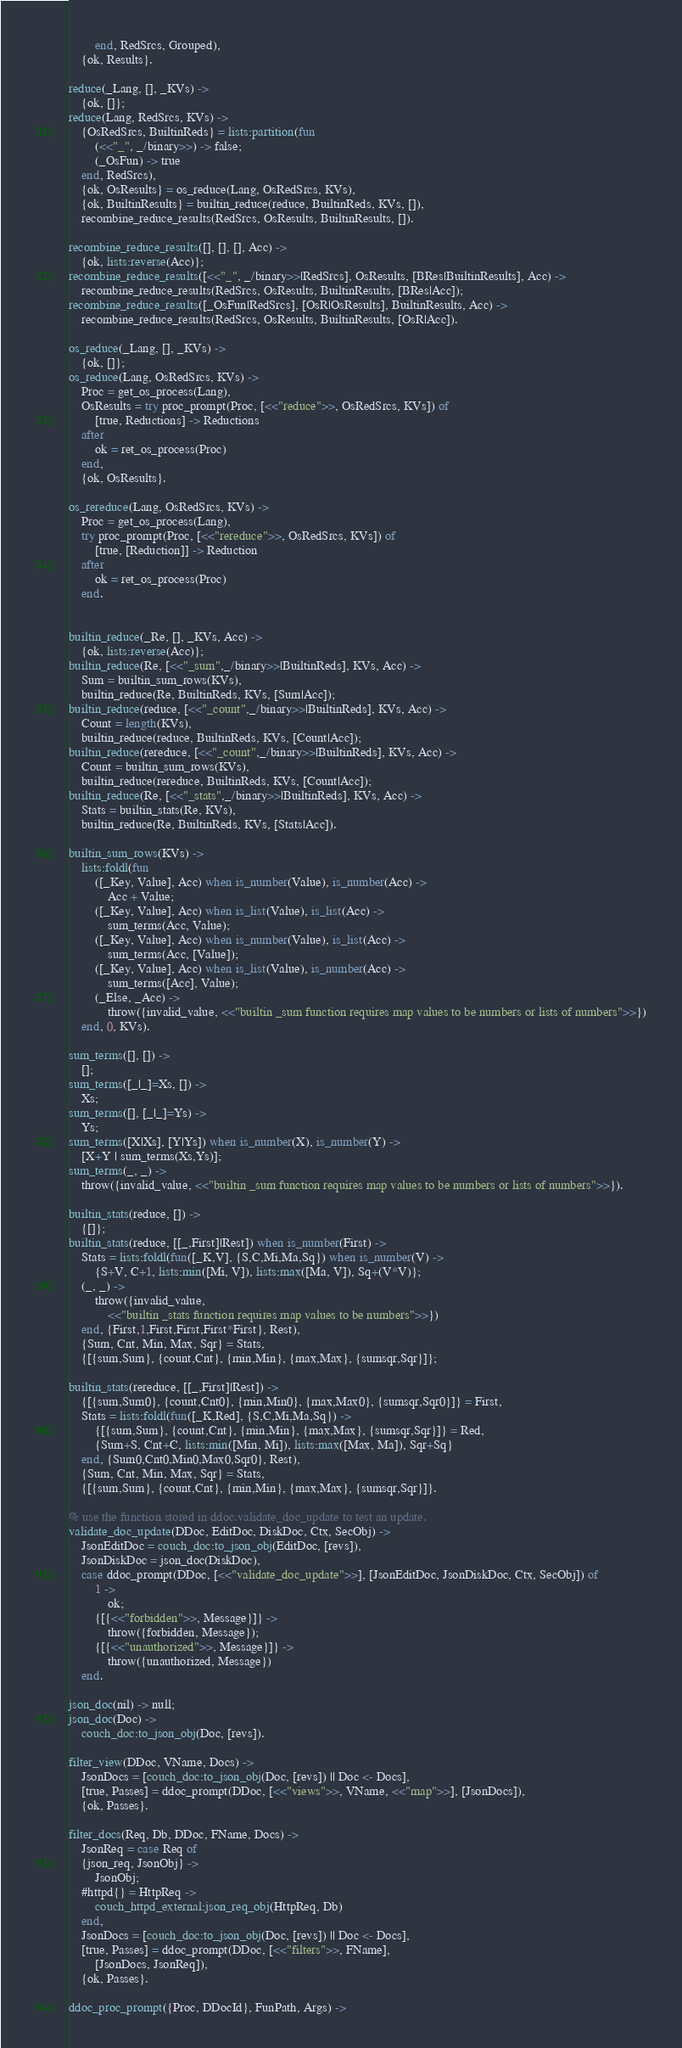Convert code to text. <code><loc_0><loc_0><loc_500><loc_500><_Erlang_>        end, RedSrcs, Grouped),
    {ok, Results}.

reduce(_Lang, [], _KVs) ->
    {ok, []};
reduce(Lang, RedSrcs, KVs) ->
    {OsRedSrcs, BuiltinReds} = lists:partition(fun
        (<<"_", _/binary>>) -> false;
        (_OsFun) -> true
    end, RedSrcs),
    {ok, OsResults} = os_reduce(Lang, OsRedSrcs, KVs),
    {ok, BuiltinResults} = builtin_reduce(reduce, BuiltinReds, KVs, []),
    recombine_reduce_results(RedSrcs, OsResults, BuiltinResults, []).

recombine_reduce_results([], [], [], Acc) ->
    {ok, lists:reverse(Acc)};
recombine_reduce_results([<<"_", _/binary>>|RedSrcs], OsResults, [BRes|BuiltinResults], Acc) ->
    recombine_reduce_results(RedSrcs, OsResults, BuiltinResults, [BRes|Acc]);
recombine_reduce_results([_OsFun|RedSrcs], [OsR|OsResults], BuiltinResults, Acc) ->
    recombine_reduce_results(RedSrcs, OsResults, BuiltinResults, [OsR|Acc]).

os_reduce(_Lang, [], _KVs) ->
    {ok, []};
os_reduce(Lang, OsRedSrcs, KVs) ->
    Proc = get_os_process(Lang),
    OsResults = try proc_prompt(Proc, [<<"reduce">>, OsRedSrcs, KVs]) of
        [true, Reductions] -> Reductions
    after
        ok = ret_os_process(Proc)
    end,
    {ok, OsResults}.

os_rereduce(Lang, OsRedSrcs, KVs) ->
    Proc = get_os_process(Lang),
    try proc_prompt(Proc, [<<"rereduce">>, OsRedSrcs, KVs]) of
        [true, [Reduction]] -> Reduction
    after
        ok = ret_os_process(Proc)
    end.


builtin_reduce(_Re, [], _KVs, Acc) ->
    {ok, lists:reverse(Acc)};
builtin_reduce(Re, [<<"_sum",_/binary>>|BuiltinReds], KVs, Acc) ->
    Sum = builtin_sum_rows(KVs),
    builtin_reduce(Re, BuiltinReds, KVs, [Sum|Acc]);
builtin_reduce(reduce, [<<"_count",_/binary>>|BuiltinReds], KVs, Acc) ->
    Count = length(KVs),
    builtin_reduce(reduce, BuiltinReds, KVs, [Count|Acc]);
builtin_reduce(rereduce, [<<"_count",_/binary>>|BuiltinReds], KVs, Acc) ->
    Count = builtin_sum_rows(KVs),
    builtin_reduce(rereduce, BuiltinReds, KVs, [Count|Acc]);
builtin_reduce(Re, [<<"_stats",_/binary>>|BuiltinReds], KVs, Acc) ->
    Stats = builtin_stats(Re, KVs),
    builtin_reduce(Re, BuiltinReds, KVs, [Stats|Acc]).

builtin_sum_rows(KVs) ->
    lists:foldl(fun
        ([_Key, Value], Acc) when is_number(Value), is_number(Acc) ->
            Acc + Value;
        ([_Key, Value], Acc) when is_list(Value), is_list(Acc) ->
            sum_terms(Acc, Value);
        ([_Key, Value], Acc) when is_number(Value), is_list(Acc) ->
            sum_terms(Acc, [Value]);
        ([_Key, Value], Acc) when is_list(Value), is_number(Acc) ->
            sum_terms([Acc], Value);
        (_Else, _Acc) ->
            throw({invalid_value, <<"builtin _sum function requires map values to be numbers or lists of numbers">>})
    end, 0, KVs).

sum_terms([], []) ->
    [];
sum_terms([_|_]=Xs, []) ->
    Xs;
sum_terms([], [_|_]=Ys) ->
    Ys;
sum_terms([X|Xs], [Y|Ys]) when is_number(X), is_number(Y) ->
    [X+Y | sum_terms(Xs,Ys)];
sum_terms(_, _) ->
    throw({invalid_value, <<"builtin _sum function requires map values to be numbers or lists of numbers">>}).

builtin_stats(reduce, []) ->
    {[]};
builtin_stats(reduce, [[_,First]|Rest]) when is_number(First) ->
    Stats = lists:foldl(fun([_K,V], {S,C,Mi,Ma,Sq}) when is_number(V) ->
        {S+V, C+1, lists:min([Mi, V]), lists:max([Ma, V]), Sq+(V*V)};
    (_, _) ->
        throw({invalid_value,
            <<"builtin _stats function requires map values to be numbers">>})
    end, {First,1,First,First,First*First}, Rest),
    {Sum, Cnt, Min, Max, Sqr} = Stats,
    {[{sum,Sum}, {count,Cnt}, {min,Min}, {max,Max}, {sumsqr,Sqr}]};

builtin_stats(rereduce, [[_,First]|Rest]) ->
    {[{sum,Sum0}, {count,Cnt0}, {min,Min0}, {max,Max0}, {sumsqr,Sqr0}]} = First,
    Stats = lists:foldl(fun([_K,Red], {S,C,Mi,Ma,Sq}) ->
        {[{sum,Sum}, {count,Cnt}, {min,Min}, {max,Max}, {sumsqr,Sqr}]} = Red,
        {Sum+S, Cnt+C, lists:min([Min, Mi]), lists:max([Max, Ma]), Sqr+Sq}
    end, {Sum0,Cnt0,Min0,Max0,Sqr0}, Rest),
    {Sum, Cnt, Min, Max, Sqr} = Stats,
    {[{sum,Sum}, {count,Cnt}, {min,Min}, {max,Max}, {sumsqr,Sqr}]}.

% use the function stored in ddoc.validate_doc_update to test an update.
validate_doc_update(DDoc, EditDoc, DiskDoc, Ctx, SecObj) ->
    JsonEditDoc = couch_doc:to_json_obj(EditDoc, [revs]),
    JsonDiskDoc = json_doc(DiskDoc),
    case ddoc_prompt(DDoc, [<<"validate_doc_update">>], [JsonEditDoc, JsonDiskDoc, Ctx, SecObj]) of
        1 ->
            ok;
        {[{<<"forbidden">>, Message}]} ->
            throw({forbidden, Message});
        {[{<<"unauthorized">>, Message}]} ->
            throw({unauthorized, Message})
    end.

json_doc(nil) -> null;
json_doc(Doc) ->
    couch_doc:to_json_obj(Doc, [revs]).

filter_view(DDoc, VName, Docs) ->
    JsonDocs = [couch_doc:to_json_obj(Doc, [revs]) || Doc <- Docs],
    [true, Passes] = ddoc_prompt(DDoc, [<<"views">>, VName, <<"map">>], [JsonDocs]),
    {ok, Passes}.

filter_docs(Req, Db, DDoc, FName, Docs) ->
    JsonReq = case Req of
    {json_req, JsonObj} ->
        JsonObj;
    #httpd{} = HttpReq ->
        couch_httpd_external:json_req_obj(HttpReq, Db)
    end,
    JsonDocs = [couch_doc:to_json_obj(Doc, [revs]) || Doc <- Docs],
    [true, Passes] = ddoc_prompt(DDoc, [<<"filters">>, FName],
        [JsonDocs, JsonReq]),
    {ok, Passes}.

ddoc_proc_prompt({Proc, DDocId}, FunPath, Args) -></code> 